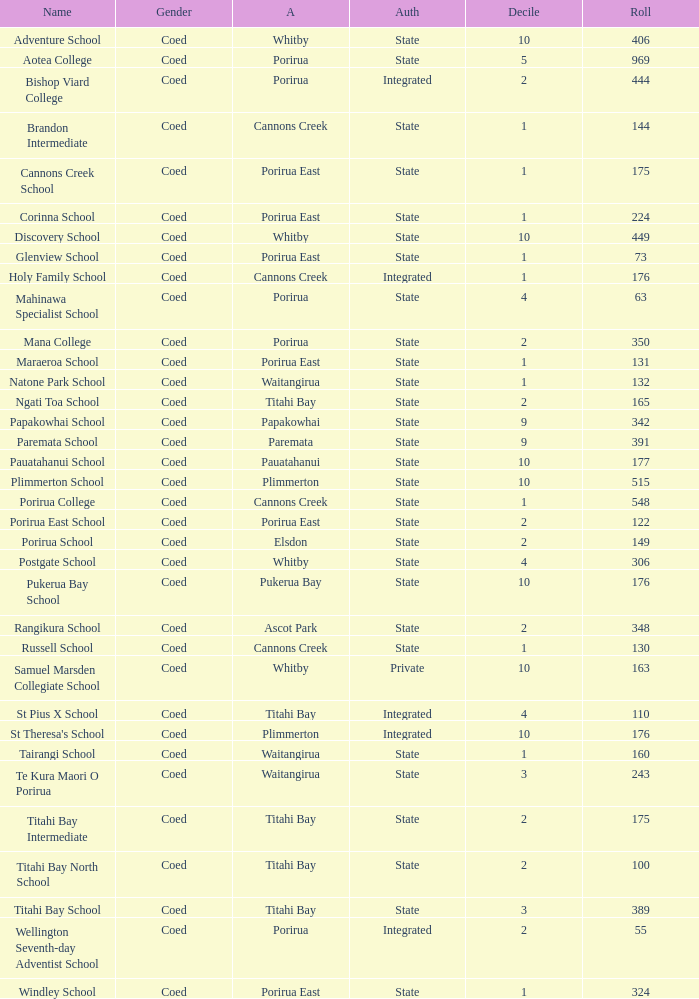What integrated school had a decile of 2 and a roll larger than 55? Bishop Viard College. 